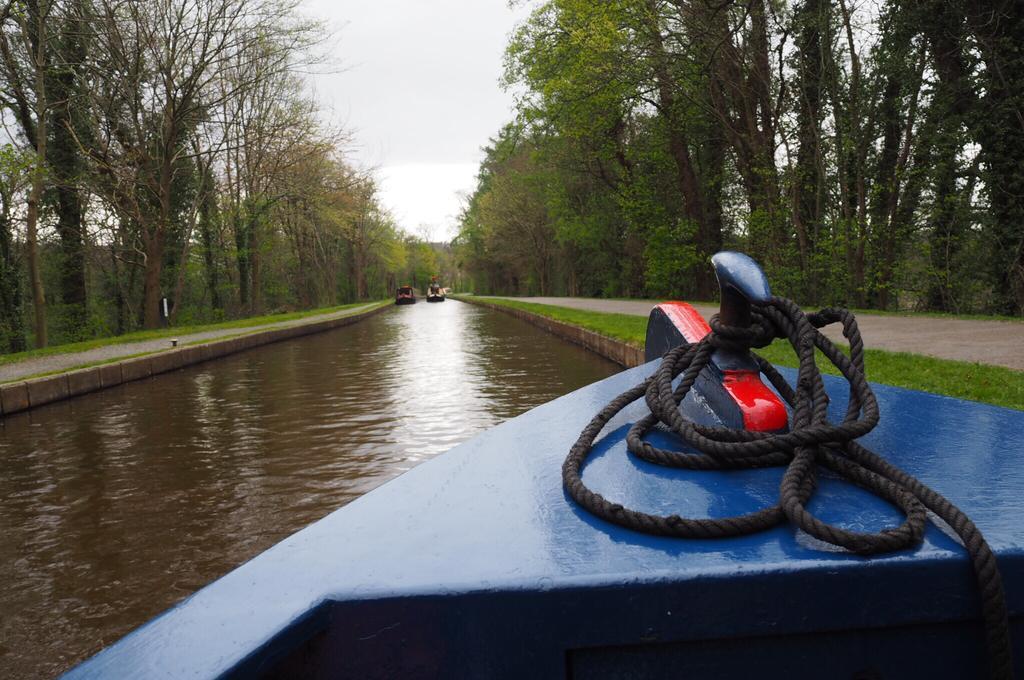In one or two sentences, can you explain what this image depicts? In this image we can see the part of a boat on the water, in front of that there are two boats. On the left and right side of the image there are trees. In the background there is the sky. 